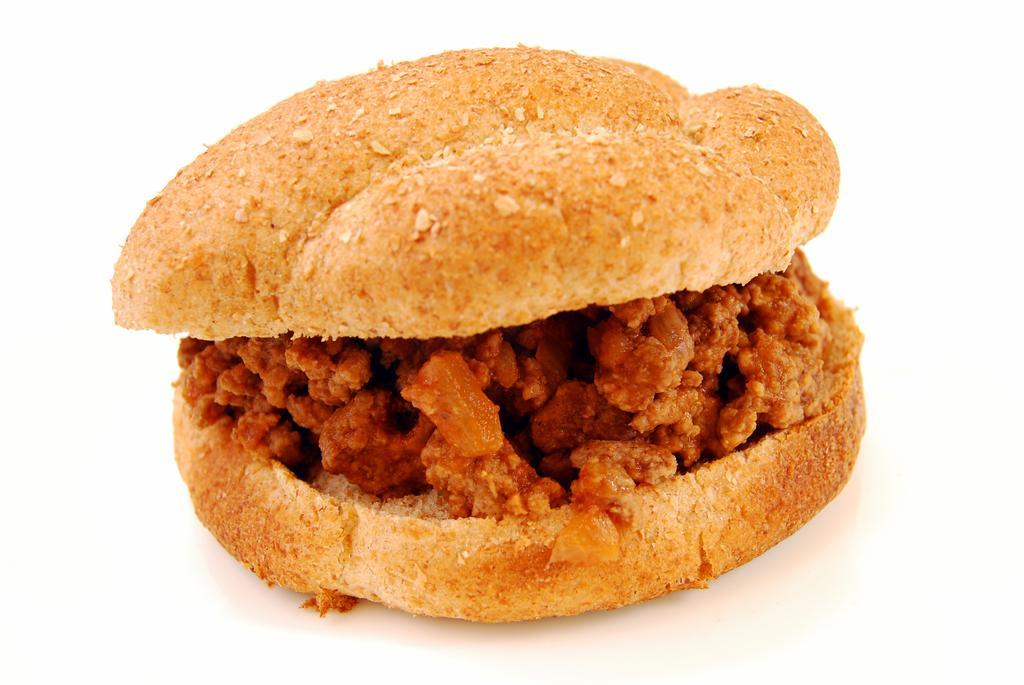Please provide a concise description of this image. In this picture I can see a burger and I can see white color background 